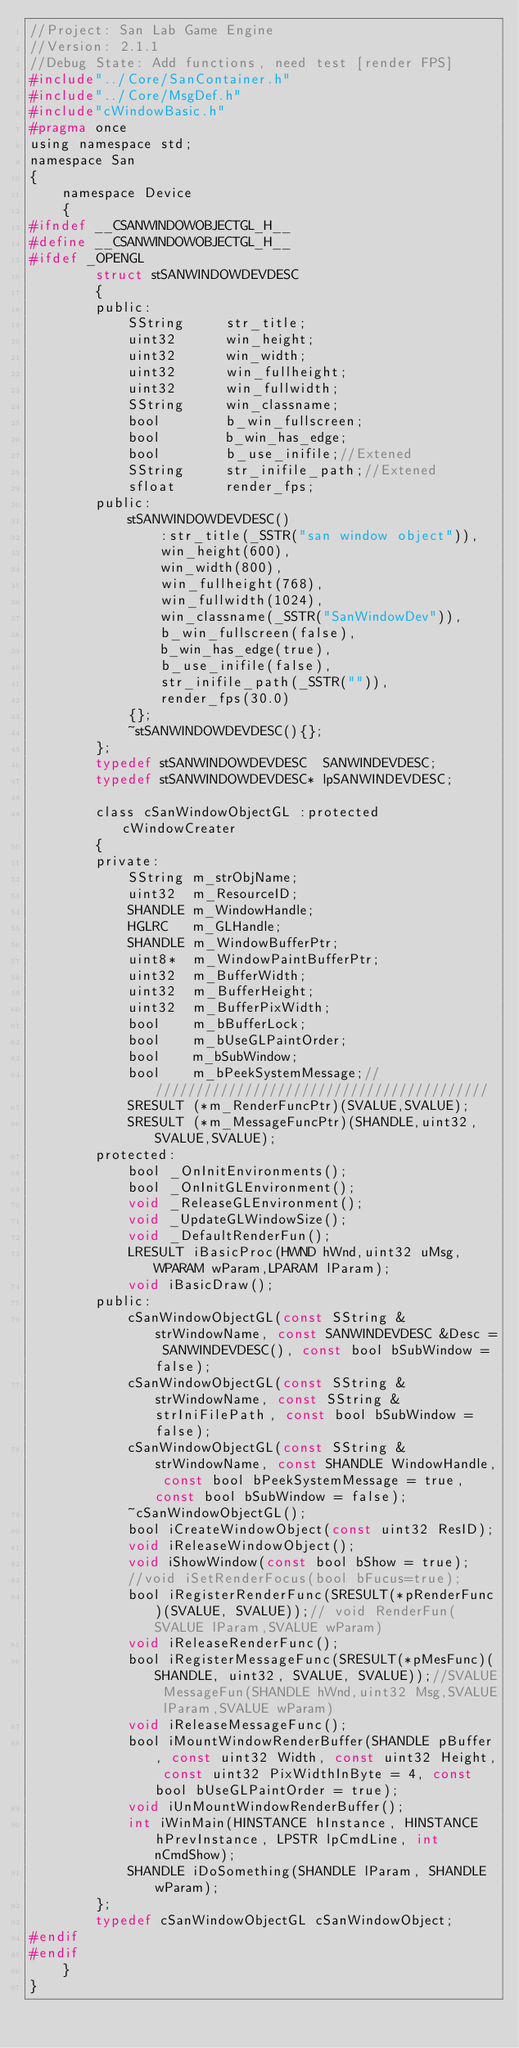<code> <loc_0><loc_0><loc_500><loc_500><_C_>//Project: San Lab Game Engine
//Version: 2.1.1
//Debug State: Add functions, need test [render FPS]
#include"../Core/SanContainer.h"
#include"../Core/MsgDef.h"
#include"cWindowBasic.h"
#pragma once
using namespace std;
namespace San
{
	namespace Device
	{
#ifndef __CSANWINDOWOBJECTGL_H__
#define __CSANWINDOWOBJECTGL_H__
#ifdef _OPENGL
		struct stSANWINDOWDEVDESC
		{
		public:
			SString		str_title;
			uint32		win_height;
			uint32		win_width;
			uint32		win_fullheight;
			uint32		win_fullwidth;
			SString		win_classname;
			bool		b_win_fullscreen;
			bool		b_win_has_edge;
			bool		b_use_inifile;//Extened
			SString		str_inifile_path;//Extened
			sfloat		render_fps;
		public:
			stSANWINDOWDEVDESC()
				:str_title(_SSTR("san window object")),
				win_height(600),
				win_width(800),
				win_fullheight(768),
				win_fullwidth(1024),
				win_classname(_SSTR("SanWindowDev")),
				b_win_fullscreen(false),
				b_win_has_edge(true),
				b_use_inifile(false),
				str_inifile_path(_SSTR("")),
				render_fps(30.0)
			{};
			~stSANWINDOWDEVDESC(){};
		};
		typedef stSANWINDOWDEVDESC	SANWINDEVDESC;
		typedef stSANWINDOWDEVDESC*	lpSANWINDEVDESC;

		class cSanWindowObjectGL :protected cWindowCreater
		{
		private:
			SString m_strObjName;
			uint32	m_ResourceID;
			SHANDLE m_WindowHandle;
			HGLRC	m_GLHandle;
			SHANDLE m_WindowBufferPtr;
			uint8*	m_WindowPaintBufferPtr;
			uint32	m_BufferWidth;
			uint32	m_BufferHeight;
			uint32	m_BufferPixWidth;
			bool	m_bBufferLock;
			bool	m_bUseGLPaintOrder;
			bool	m_bSubWindow;
			bool	m_bPeekSystemMessage;///////////////////////////////////////////
			SRESULT	(*m_RenderFuncPtr)(SVALUE,SVALUE);
			SRESULT	(*m_MessageFuncPtr)(SHANDLE,uint32,SVALUE,SVALUE);
		protected:
			bool _OnInitEnvironments();
			bool _OnInitGLEnvironment();
			void _ReleaseGLEnvironment();
			void _UpdateGLWindowSize();
			void _DefaultRenderFun();
			LRESULT iBasicProc(HWND hWnd,uint32 uMsg,WPARAM wParam,LPARAM lParam);
			void iBasicDraw();
		public:
			cSanWindowObjectGL(const SString &strWindowName, const SANWINDEVDESC &Desc = SANWINDEVDESC(), const bool bSubWindow = false);
			cSanWindowObjectGL(const SString &strWindowName, const SString &strIniFilePath, const bool bSubWindow = false);
			cSanWindowObjectGL(const SString &strWindowName, const SHANDLE WindowHandle, const bool bPeekSystemMessage = true, const bool bSubWindow = false);
			~cSanWindowObjectGL();
			bool iCreateWindowObject(const uint32 ResID);
			void iReleaseWindowObject();
			void iShowWindow(const bool bShow = true);
			//void iSetRenderFocus(bool bFucus=true);
			bool iRegisterRenderFunc(SRESULT(*pRenderFunc)(SVALUE, SVALUE));// void RenderFun(SVALUE lParam,SVALUE wParam)
			void iReleaseRenderFunc();
			bool iRegisterMessageFunc(SRESULT(*pMesFunc)(SHANDLE, uint32, SVALUE, SVALUE));//SVALUE MessageFun(SHANDLE hWnd,uint32 Msg,SVALUE lParam,SVALUE wParam)
			void iReleaseMessageFunc();
			bool iMountWindowRenderBuffer(SHANDLE pBuffer, const uint32 Width, const uint32 Height, const uint32 PixWidthInByte = 4, const bool bUseGLPaintOrder = true);
			void iUnMountWindowRenderBuffer();
			int iWinMain(HINSTANCE hInstance, HINSTANCE hPrevInstance, LPSTR lpCmdLine, int nCmdShow);
			SHANDLE iDoSomething(SHANDLE lParam, SHANDLE wParam);
		};
		typedef cSanWindowObjectGL cSanWindowObject;
#endif
#endif
	}
}</code> 